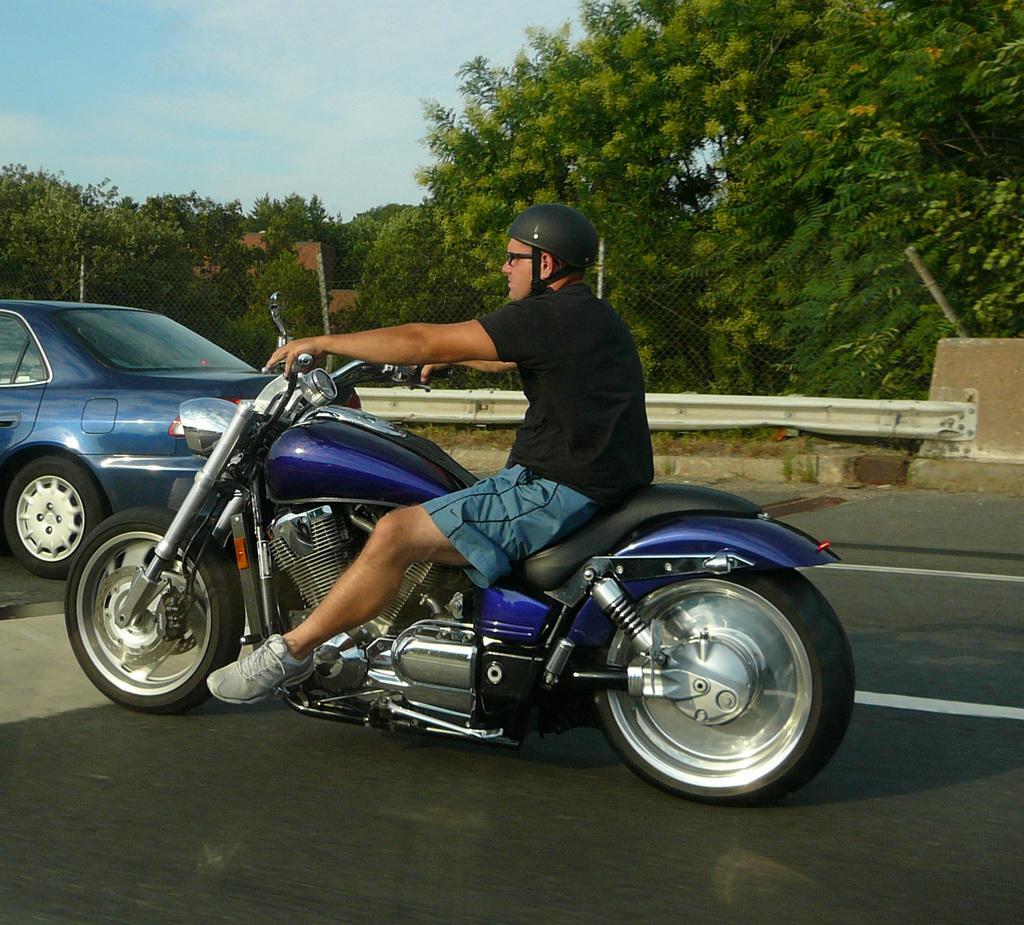Can you describe this image briefly? Here we can see a man on a motorcycle. He is wearing a helmet. There is a car on the top left. In the background we can see trees and a sky with clouds. 